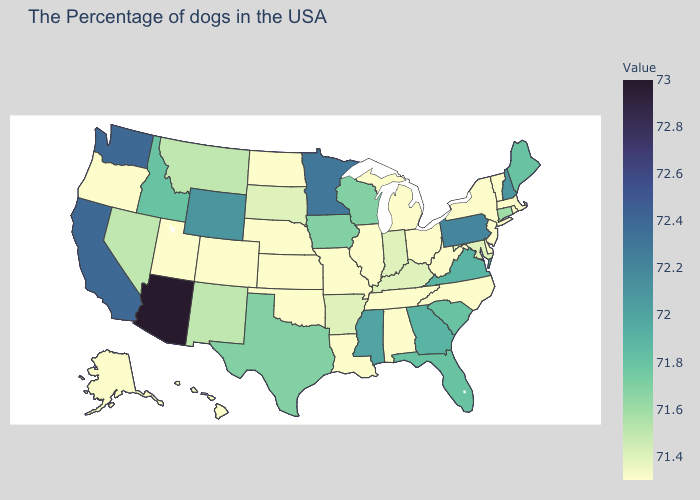Does the map have missing data?
Give a very brief answer. No. Is the legend a continuous bar?
Concise answer only. Yes. Does the map have missing data?
Keep it brief. No. Is the legend a continuous bar?
Give a very brief answer. Yes. Does Minnesota have a higher value than Idaho?
Quick response, please. Yes. Among the states that border South Carolina , which have the highest value?
Write a very short answer. Georgia. 